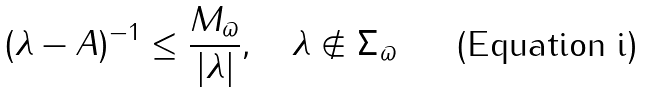<formula> <loc_0><loc_0><loc_500><loc_500>\| ( \lambda - A ) ^ { - 1 } \| \leq \frac { M _ { \varpi } } { | \lambda | } , \quad \lambda \notin \Sigma _ { \varpi }</formula> 